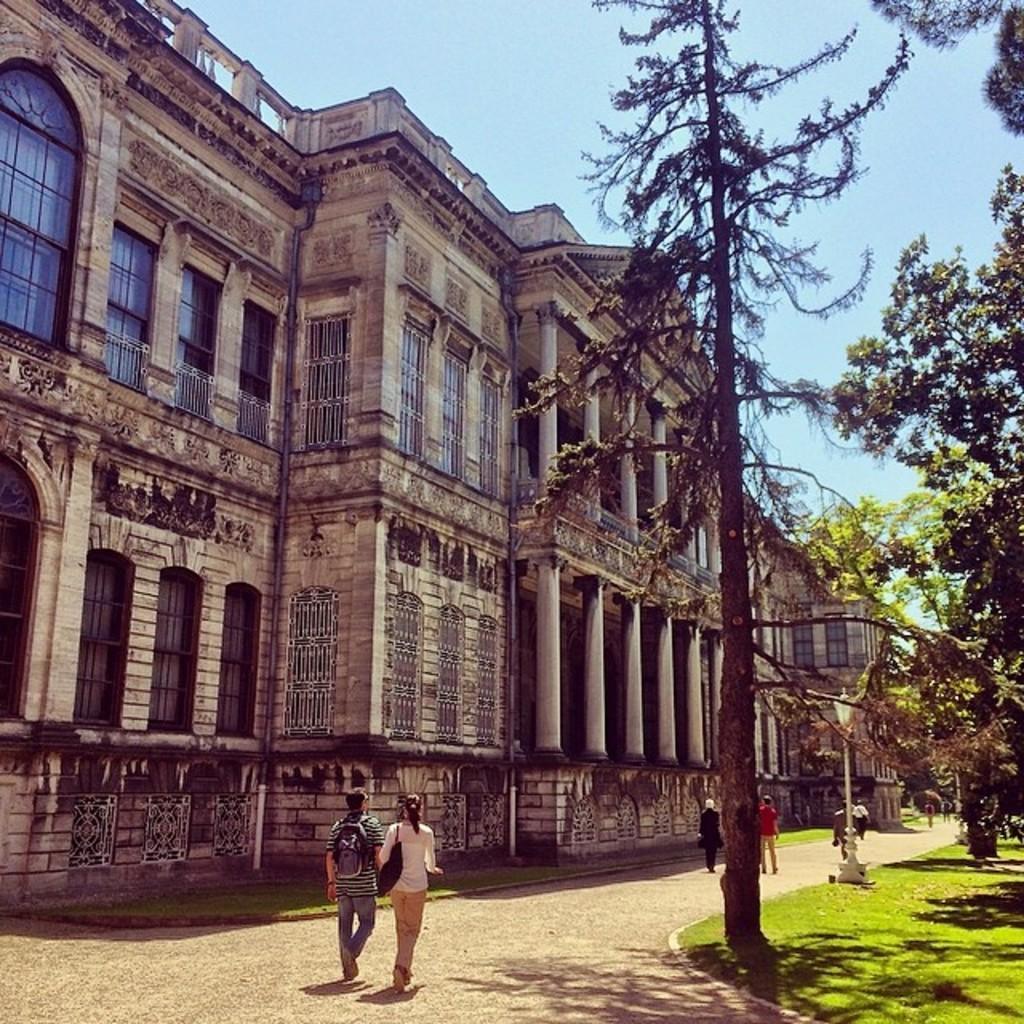Can you describe this image briefly? In this image there is a building and road. On the road there are persons walking and holding bags. And in front of the building there are trees, Grass and a light pole. And at the top there is a sky. 